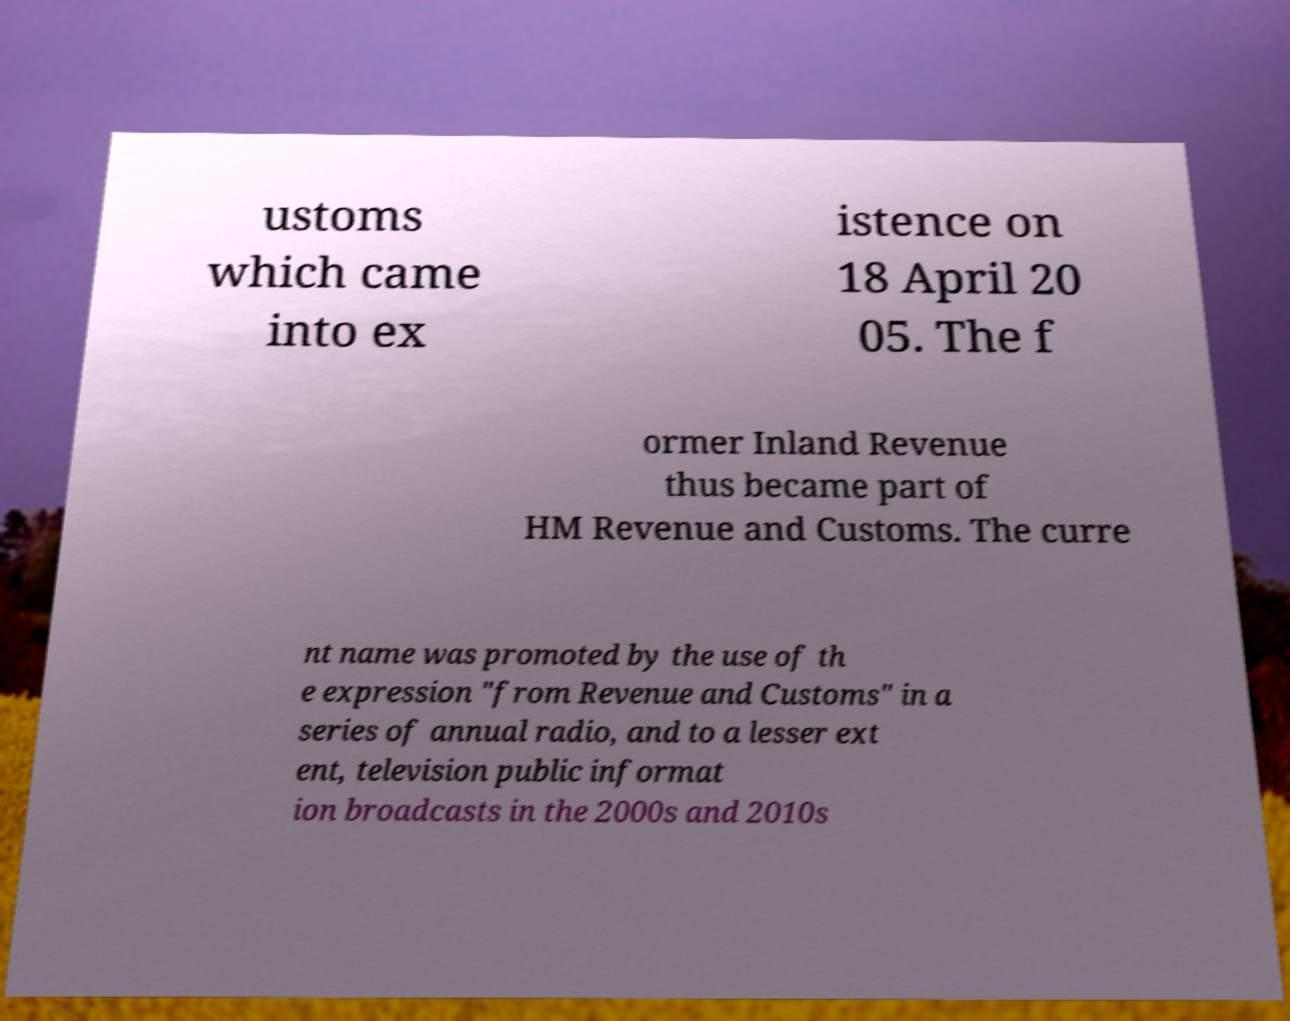Can you accurately transcribe the text from the provided image for me? ustoms which came into ex istence on 18 April 20 05. The f ormer Inland Revenue thus became part of HM Revenue and Customs. The curre nt name was promoted by the use of th e expression "from Revenue and Customs" in a series of annual radio, and to a lesser ext ent, television public informat ion broadcasts in the 2000s and 2010s 